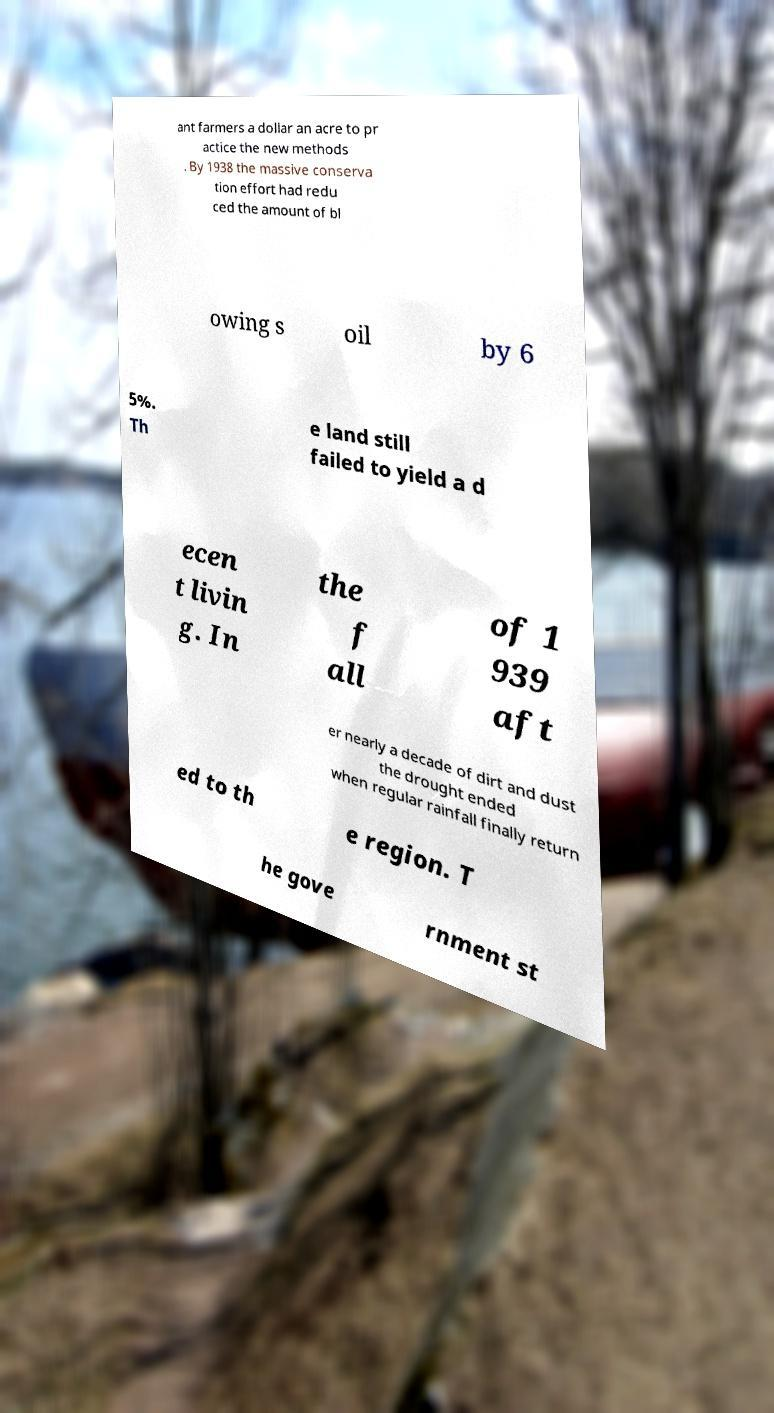I need the written content from this picture converted into text. Can you do that? ant farmers a dollar an acre to pr actice the new methods . By 1938 the massive conserva tion effort had redu ced the amount of bl owing s oil by 6 5%. Th e land still failed to yield a d ecen t livin g. In the f all of 1 939 aft er nearly a decade of dirt and dust the drought ended when regular rainfall finally return ed to th e region. T he gove rnment st 